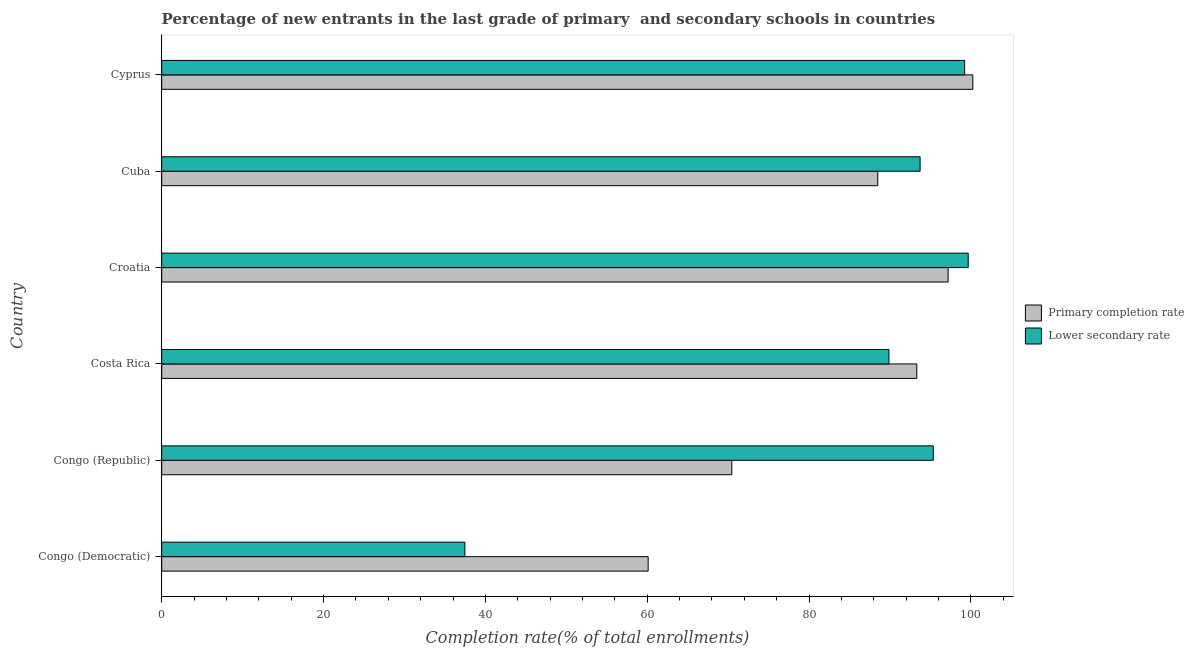How many different coloured bars are there?
Make the answer very short. 2. How many groups of bars are there?
Give a very brief answer. 6. Are the number of bars per tick equal to the number of legend labels?
Make the answer very short. Yes. Are the number of bars on each tick of the Y-axis equal?
Provide a short and direct response. Yes. How many bars are there on the 2nd tick from the top?
Offer a very short reply. 2. How many bars are there on the 2nd tick from the bottom?
Your answer should be compact. 2. What is the label of the 1st group of bars from the top?
Make the answer very short. Cyprus. In how many cases, is the number of bars for a given country not equal to the number of legend labels?
Ensure brevity in your answer.  0. What is the completion rate in secondary schools in Cyprus?
Ensure brevity in your answer.  99.23. Across all countries, what is the maximum completion rate in primary schools?
Give a very brief answer. 100.25. Across all countries, what is the minimum completion rate in secondary schools?
Your answer should be compact. 37.47. In which country was the completion rate in primary schools maximum?
Offer a terse response. Cyprus. In which country was the completion rate in secondary schools minimum?
Make the answer very short. Congo (Democratic). What is the total completion rate in primary schools in the graph?
Your answer should be very brief. 509.83. What is the difference between the completion rate in primary schools in Costa Rica and that in Croatia?
Provide a short and direct response. -3.87. What is the difference between the completion rate in primary schools in Congo (Democratic) and the completion rate in secondary schools in Cyprus?
Provide a short and direct response. -39.11. What is the average completion rate in secondary schools per country?
Ensure brevity in your answer.  85.89. What is the difference between the completion rate in primary schools and completion rate in secondary schools in Costa Rica?
Give a very brief answer. 3.45. What is the ratio of the completion rate in secondary schools in Costa Rica to that in Cyprus?
Provide a short and direct response. 0.91. Is the difference between the completion rate in primary schools in Congo (Democratic) and Congo (Republic) greater than the difference between the completion rate in secondary schools in Congo (Democratic) and Congo (Republic)?
Your answer should be compact. Yes. What is the difference between the highest and the second highest completion rate in secondary schools?
Your answer should be compact. 0.44. What is the difference between the highest and the lowest completion rate in secondary schools?
Your response must be concise. 62.21. In how many countries, is the completion rate in secondary schools greater than the average completion rate in secondary schools taken over all countries?
Your answer should be compact. 5. Is the sum of the completion rate in primary schools in Congo (Democratic) and Congo (Republic) greater than the maximum completion rate in secondary schools across all countries?
Provide a succinct answer. Yes. What does the 1st bar from the top in Croatia represents?
Your response must be concise. Lower secondary rate. What does the 2nd bar from the bottom in Congo (Democratic) represents?
Your answer should be compact. Lower secondary rate. Are all the bars in the graph horizontal?
Your answer should be very brief. Yes. How many countries are there in the graph?
Your response must be concise. 6. What is the difference between two consecutive major ticks on the X-axis?
Your answer should be compact. 20. Does the graph contain grids?
Make the answer very short. No. Where does the legend appear in the graph?
Give a very brief answer. Center right. How many legend labels are there?
Keep it short and to the point. 2. How are the legend labels stacked?
Give a very brief answer. Vertical. What is the title of the graph?
Make the answer very short. Percentage of new entrants in the last grade of primary  and secondary schools in countries. Does "Excluding technical cooperation" appear as one of the legend labels in the graph?
Ensure brevity in your answer.  No. What is the label or title of the X-axis?
Your answer should be very brief. Completion rate(% of total enrollments). What is the Completion rate(% of total enrollments) of Primary completion rate in Congo (Democratic)?
Give a very brief answer. 60.12. What is the Completion rate(% of total enrollments) in Lower secondary rate in Congo (Democratic)?
Your response must be concise. 37.47. What is the Completion rate(% of total enrollments) in Primary completion rate in Congo (Republic)?
Offer a terse response. 70.46. What is the Completion rate(% of total enrollments) in Lower secondary rate in Congo (Republic)?
Ensure brevity in your answer.  95.36. What is the Completion rate(% of total enrollments) of Primary completion rate in Costa Rica?
Your response must be concise. 93.32. What is the Completion rate(% of total enrollments) in Lower secondary rate in Costa Rica?
Ensure brevity in your answer.  89.87. What is the Completion rate(% of total enrollments) in Primary completion rate in Croatia?
Your answer should be very brief. 97.19. What is the Completion rate(% of total enrollments) in Lower secondary rate in Croatia?
Offer a terse response. 99.68. What is the Completion rate(% of total enrollments) of Primary completion rate in Cuba?
Keep it short and to the point. 88.5. What is the Completion rate(% of total enrollments) in Lower secondary rate in Cuba?
Ensure brevity in your answer.  93.73. What is the Completion rate(% of total enrollments) of Primary completion rate in Cyprus?
Ensure brevity in your answer.  100.25. What is the Completion rate(% of total enrollments) of Lower secondary rate in Cyprus?
Provide a short and direct response. 99.23. Across all countries, what is the maximum Completion rate(% of total enrollments) of Primary completion rate?
Ensure brevity in your answer.  100.25. Across all countries, what is the maximum Completion rate(% of total enrollments) of Lower secondary rate?
Provide a short and direct response. 99.68. Across all countries, what is the minimum Completion rate(% of total enrollments) in Primary completion rate?
Offer a very short reply. 60.12. Across all countries, what is the minimum Completion rate(% of total enrollments) in Lower secondary rate?
Provide a succinct answer. 37.47. What is the total Completion rate(% of total enrollments) in Primary completion rate in the graph?
Your answer should be compact. 509.83. What is the total Completion rate(% of total enrollments) of Lower secondary rate in the graph?
Make the answer very short. 515.33. What is the difference between the Completion rate(% of total enrollments) in Primary completion rate in Congo (Democratic) and that in Congo (Republic)?
Provide a short and direct response. -10.34. What is the difference between the Completion rate(% of total enrollments) of Lower secondary rate in Congo (Democratic) and that in Congo (Republic)?
Provide a short and direct response. -57.89. What is the difference between the Completion rate(% of total enrollments) in Primary completion rate in Congo (Democratic) and that in Costa Rica?
Your response must be concise. -33.2. What is the difference between the Completion rate(% of total enrollments) of Lower secondary rate in Congo (Democratic) and that in Costa Rica?
Your response must be concise. -52.41. What is the difference between the Completion rate(% of total enrollments) in Primary completion rate in Congo (Democratic) and that in Croatia?
Keep it short and to the point. -37.07. What is the difference between the Completion rate(% of total enrollments) in Lower secondary rate in Congo (Democratic) and that in Croatia?
Provide a succinct answer. -62.21. What is the difference between the Completion rate(% of total enrollments) in Primary completion rate in Congo (Democratic) and that in Cuba?
Provide a short and direct response. -28.38. What is the difference between the Completion rate(% of total enrollments) of Lower secondary rate in Congo (Democratic) and that in Cuba?
Offer a terse response. -56.26. What is the difference between the Completion rate(% of total enrollments) of Primary completion rate in Congo (Democratic) and that in Cyprus?
Your response must be concise. -40.13. What is the difference between the Completion rate(% of total enrollments) of Lower secondary rate in Congo (Democratic) and that in Cyprus?
Your answer should be compact. -61.77. What is the difference between the Completion rate(% of total enrollments) of Primary completion rate in Congo (Republic) and that in Costa Rica?
Keep it short and to the point. -22.86. What is the difference between the Completion rate(% of total enrollments) of Lower secondary rate in Congo (Republic) and that in Costa Rica?
Ensure brevity in your answer.  5.48. What is the difference between the Completion rate(% of total enrollments) of Primary completion rate in Congo (Republic) and that in Croatia?
Offer a terse response. -26.73. What is the difference between the Completion rate(% of total enrollments) of Lower secondary rate in Congo (Republic) and that in Croatia?
Provide a succinct answer. -4.32. What is the difference between the Completion rate(% of total enrollments) in Primary completion rate in Congo (Republic) and that in Cuba?
Offer a very short reply. -18.04. What is the difference between the Completion rate(% of total enrollments) of Lower secondary rate in Congo (Republic) and that in Cuba?
Offer a terse response. 1.63. What is the difference between the Completion rate(% of total enrollments) of Primary completion rate in Congo (Republic) and that in Cyprus?
Keep it short and to the point. -29.79. What is the difference between the Completion rate(% of total enrollments) in Lower secondary rate in Congo (Republic) and that in Cyprus?
Ensure brevity in your answer.  -3.88. What is the difference between the Completion rate(% of total enrollments) in Primary completion rate in Costa Rica and that in Croatia?
Your answer should be compact. -3.87. What is the difference between the Completion rate(% of total enrollments) in Lower secondary rate in Costa Rica and that in Croatia?
Your answer should be compact. -9.8. What is the difference between the Completion rate(% of total enrollments) of Primary completion rate in Costa Rica and that in Cuba?
Offer a terse response. 4.82. What is the difference between the Completion rate(% of total enrollments) of Lower secondary rate in Costa Rica and that in Cuba?
Your answer should be very brief. -3.85. What is the difference between the Completion rate(% of total enrollments) in Primary completion rate in Costa Rica and that in Cyprus?
Ensure brevity in your answer.  -6.93. What is the difference between the Completion rate(% of total enrollments) of Lower secondary rate in Costa Rica and that in Cyprus?
Make the answer very short. -9.36. What is the difference between the Completion rate(% of total enrollments) of Primary completion rate in Croatia and that in Cuba?
Make the answer very short. 8.7. What is the difference between the Completion rate(% of total enrollments) of Lower secondary rate in Croatia and that in Cuba?
Your response must be concise. 5.95. What is the difference between the Completion rate(% of total enrollments) of Primary completion rate in Croatia and that in Cyprus?
Offer a terse response. -3.05. What is the difference between the Completion rate(% of total enrollments) of Lower secondary rate in Croatia and that in Cyprus?
Your response must be concise. 0.44. What is the difference between the Completion rate(% of total enrollments) in Primary completion rate in Cuba and that in Cyprus?
Offer a very short reply. -11.75. What is the difference between the Completion rate(% of total enrollments) of Lower secondary rate in Cuba and that in Cyprus?
Provide a short and direct response. -5.51. What is the difference between the Completion rate(% of total enrollments) in Primary completion rate in Congo (Democratic) and the Completion rate(% of total enrollments) in Lower secondary rate in Congo (Republic)?
Give a very brief answer. -35.24. What is the difference between the Completion rate(% of total enrollments) of Primary completion rate in Congo (Democratic) and the Completion rate(% of total enrollments) of Lower secondary rate in Costa Rica?
Keep it short and to the point. -29.76. What is the difference between the Completion rate(% of total enrollments) in Primary completion rate in Congo (Democratic) and the Completion rate(% of total enrollments) in Lower secondary rate in Croatia?
Provide a short and direct response. -39.56. What is the difference between the Completion rate(% of total enrollments) of Primary completion rate in Congo (Democratic) and the Completion rate(% of total enrollments) of Lower secondary rate in Cuba?
Provide a short and direct response. -33.61. What is the difference between the Completion rate(% of total enrollments) of Primary completion rate in Congo (Democratic) and the Completion rate(% of total enrollments) of Lower secondary rate in Cyprus?
Offer a terse response. -39.11. What is the difference between the Completion rate(% of total enrollments) in Primary completion rate in Congo (Republic) and the Completion rate(% of total enrollments) in Lower secondary rate in Costa Rica?
Keep it short and to the point. -19.42. What is the difference between the Completion rate(% of total enrollments) of Primary completion rate in Congo (Republic) and the Completion rate(% of total enrollments) of Lower secondary rate in Croatia?
Provide a short and direct response. -29.22. What is the difference between the Completion rate(% of total enrollments) in Primary completion rate in Congo (Republic) and the Completion rate(% of total enrollments) in Lower secondary rate in Cuba?
Make the answer very short. -23.27. What is the difference between the Completion rate(% of total enrollments) in Primary completion rate in Congo (Republic) and the Completion rate(% of total enrollments) in Lower secondary rate in Cyprus?
Provide a succinct answer. -28.78. What is the difference between the Completion rate(% of total enrollments) in Primary completion rate in Costa Rica and the Completion rate(% of total enrollments) in Lower secondary rate in Croatia?
Your answer should be very brief. -6.35. What is the difference between the Completion rate(% of total enrollments) in Primary completion rate in Costa Rica and the Completion rate(% of total enrollments) in Lower secondary rate in Cuba?
Keep it short and to the point. -0.41. What is the difference between the Completion rate(% of total enrollments) in Primary completion rate in Costa Rica and the Completion rate(% of total enrollments) in Lower secondary rate in Cyprus?
Your answer should be compact. -5.91. What is the difference between the Completion rate(% of total enrollments) in Primary completion rate in Croatia and the Completion rate(% of total enrollments) in Lower secondary rate in Cuba?
Your answer should be very brief. 3.47. What is the difference between the Completion rate(% of total enrollments) of Primary completion rate in Croatia and the Completion rate(% of total enrollments) of Lower secondary rate in Cyprus?
Your answer should be very brief. -2.04. What is the difference between the Completion rate(% of total enrollments) of Primary completion rate in Cuba and the Completion rate(% of total enrollments) of Lower secondary rate in Cyprus?
Your answer should be compact. -10.74. What is the average Completion rate(% of total enrollments) of Primary completion rate per country?
Offer a terse response. 84.97. What is the average Completion rate(% of total enrollments) of Lower secondary rate per country?
Your answer should be compact. 85.89. What is the difference between the Completion rate(% of total enrollments) in Primary completion rate and Completion rate(% of total enrollments) in Lower secondary rate in Congo (Democratic)?
Ensure brevity in your answer.  22.65. What is the difference between the Completion rate(% of total enrollments) in Primary completion rate and Completion rate(% of total enrollments) in Lower secondary rate in Congo (Republic)?
Your answer should be very brief. -24.9. What is the difference between the Completion rate(% of total enrollments) of Primary completion rate and Completion rate(% of total enrollments) of Lower secondary rate in Costa Rica?
Make the answer very short. 3.45. What is the difference between the Completion rate(% of total enrollments) in Primary completion rate and Completion rate(% of total enrollments) in Lower secondary rate in Croatia?
Offer a very short reply. -2.48. What is the difference between the Completion rate(% of total enrollments) of Primary completion rate and Completion rate(% of total enrollments) of Lower secondary rate in Cuba?
Your answer should be compact. -5.23. What is the difference between the Completion rate(% of total enrollments) of Primary completion rate and Completion rate(% of total enrollments) of Lower secondary rate in Cyprus?
Make the answer very short. 1.01. What is the ratio of the Completion rate(% of total enrollments) of Primary completion rate in Congo (Democratic) to that in Congo (Republic)?
Offer a terse response. 0.85. What is the ratio of the Completion rate(% of total enrollments) of Lower secondary rate in Congo (Democratic) to that in Congo (Republic)?
Provide a succinct answer. 0.39. What is the ratio of the Completion rate(% of total enrollments) of Primary completion rate in Congo (Democratic) to that in Costa Rica?
Give a very brief answer. 0.64. What is the ratio of the Completion rate(% of total enrollments) of Lower secondary rate in Congo (Democratic) to that in Costa Rica?
Offer a very short reply. 0.42. What is the ratio of the Completion rate(% of total enrollments) in Primary completion rate in Congo (Democratic) to that in Croatia?
Ensure brevity in your answer.  0.62. What is the ratio of the Completion rate(% of total enrollments) in Lower secondary rate in Congo (Democratic) to that in Croatia?
Make the answer very short. 0.38. What is the ratio of the Completion rate(% of total enrollments) in Primary completion rate in Congo (Democratic) to that in Cuba?
Provide a succinct answer. 0.68. What is the ratio of the Completion rate(% of total enrollments) of Lower secondary rate in Congo (Democratic) to that in Cuba?
Offer a terse response. 0.4. What is the ratio of the Completion rate(% of total enrollments) of Primary completion rate in Congo (Democratic) to that in Cyprus?
Make the answer very short. 0.6. What is the ratio of the Completion rate(% of total enrollments) of Lower secondary rate in Congo (Democratic) to that in Cyprus?
Your answer should be very brief. 0.38. What is the ratio of the Completion rate(% of total enrollments) in Primary completion rate in Congo (Republic) to that in Costa Rica?
Ensure brevity in your answer.  0.76. What is the ratio of the Completion rate(% of total enrollments) in Lower secondary rate in Congo (Republic) to that in Costa Rica?
Offer a very short reply. 1.06. What is the ratio of the Completion rate(% of total enrollments) of Primary completion rate in Congo (Republic) to that in Croatia?
Your answer should be compact. 0.72. What is the ratio of the Completion rate(% of total enrollments) of Lower secondary rate in Congo (Republic) to that in Croatia?
Offer a terse response. 0.96. What is the ratio of the Completion rate(% of total enrollments) in Primary completion rate in Congo (Republic) to that in Cuba?
Offer a very short reply. 0.8. What is the ratio of the Completion rate(% of total enrollments) of Lower secondary rate in Congo (Republic) to that in Cuba?
Keep it short and to the point. 1.02. What is the ratio of the Completion rate(% of total enrollments) of Primary completion rate in Congo (Republic) to that in Cyprus?
Provide a succinct answer. 0.7. What is the ratio of the Completion rate(% of total enrollments) in Lower secondary rate in Congo (Republic) to that in Cyprus?
Your response must be concise. 0.96. What is the ratio of the Completion rate(% of total enrollments) in Primary completion rate in Costa Rica to that in Croatia?
Ensure brevity in your answer.  0.96. What is the ratio of the Completion rate(% of total enrollments) of Lower secondary rate in Costa Rica to that in Croatia?
Ensure brevity in your answer.  0.9. What is the ratio of the Completion rate(% of total enrollments) in Primary completion rate in Costa Rica to that in Cuba?
Make the answer very short. 1.05. What is the ratio of the Completion rate(% of total enrollments) of Lower secondary rate in Costa Rica to that in Cuba?
Offer a terse response. 0.96. What is the ratio of the Completion rate(% of total enrollments) of Primary completion rate in Costa Rica to that in Cyprus?
Your answer should be very brief. 0.93. What is the ratio of the Completion rate(% of total enrollments) in Lower secondary rate in Costa Rica to that in Cyprus?
Offer a very short reply. 0.91. What is the ratio of the Completion rate(% of total enrollments) of Primary completion rate in Croatia to that in Cuba?
Ensure brevity in your answer.  1.1. What is the ratio of the Completion rate(% of total enrollments) of Lower secondary rate in Croatia to that in Cuba?
Offer a terse response. 1.06. What is the ratio of the Completion rate(% of total enrollments) in Primary completion rate in Croatia to that in Cyprus?
Offer a very short reply. 0.97. What is the ratio of the Completion rate(% of total enrollments) of Primary completion rate in Cuba to that in Cyprus?
Ensure brevity in your answer.  0.88. What is the ratio of the Completion rate(% of total enrollments) of Lower secondary rate in Cuba to that in Cyprus?
Keep it short and to the point. 0.94. What is the difference between the highest and the second highest Completion rate(% of total enrollments) in Primary completion rate?
Your answer should be very brief. 3.05. What is the difference between the highest and the second highest Completion rate(% of total enrollments) in Lower secondary rate?
Ensure brevity in your answer.  0.44. What is the difference between the highest and the lowest Completion rate(% of total enrollments) in Primary completion rate?
Your answer should be very brief. 40.13. What is the difference between the highest and the lowest Completion rate(% of total enrollments) in Lower secondary rate?
Keep it short and to the point. 62.21. 